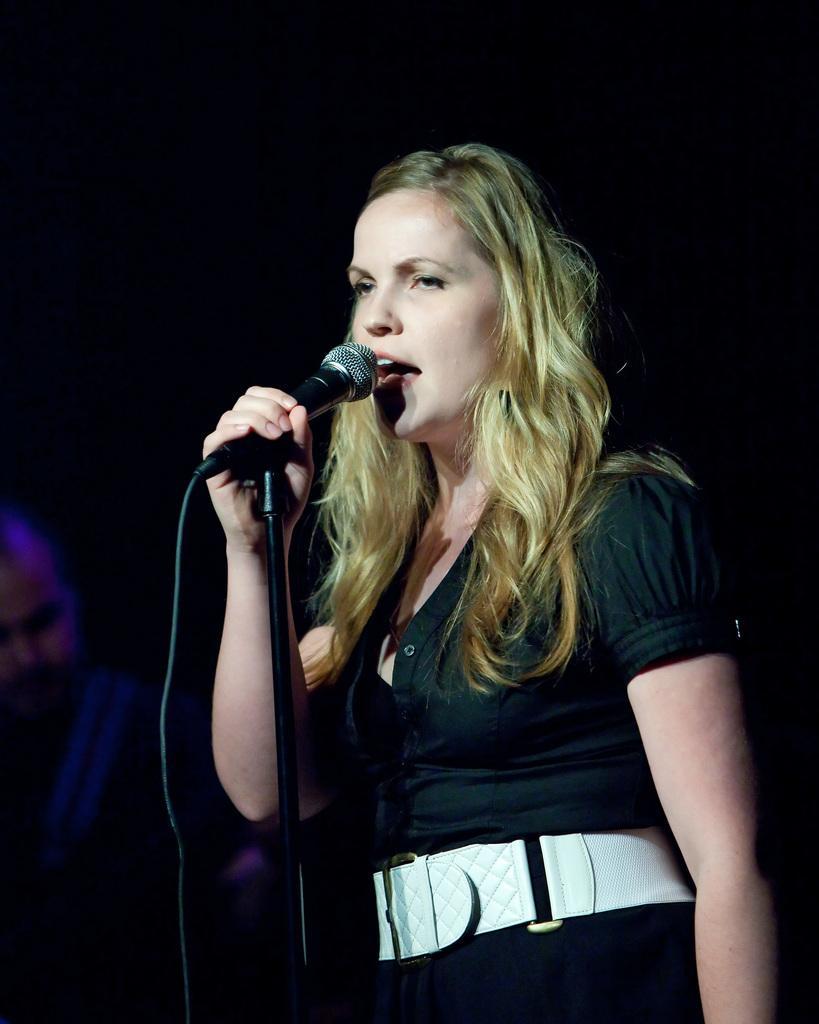How would you summarize this image in a sentence or two? In the image there is a woman standing and singing. She is holding microphone in her hand. The background is dark.  